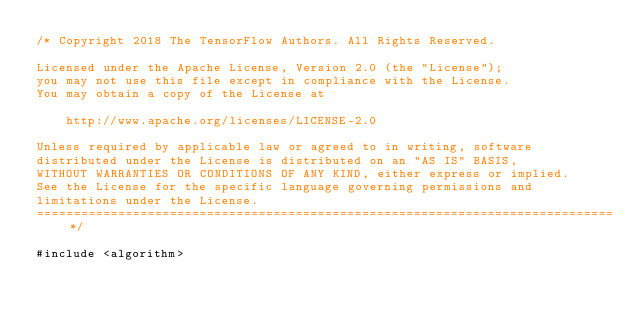Convert code to text. <code><loc_0><loc_0><loc_500><loc_500><_C++_>/* Copyright 2018 The TensorFlow Authors. All Rights Reserved.

Licensed under the Apache License, Version 2.0 (the "License");
you may not use this file except in compliance with the License.
You may obtain a copy of the License at

    http://www.apache.org/licenses/LICENSE-2.0

Unless required by applicable law or agreed to in writing, software
distributed under the License is distributed on an "AS IS" BASIS,
WITHOUT WARRANTIES OR CONDITIONS OF ANY KIND, either express or implied.
See the License for the specific language governing permissions and
limitations under the License.
==============================================================================*/

#include <algorithm>
</code> 